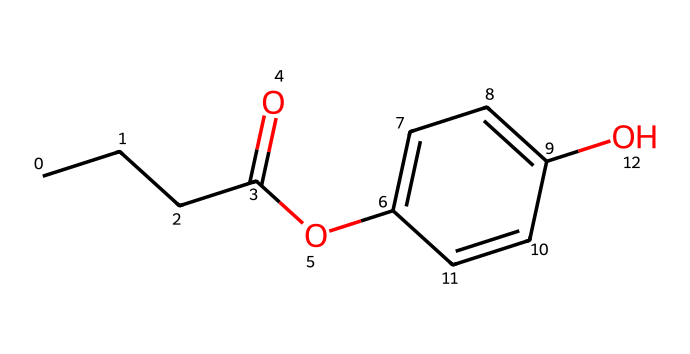What is the chemical name represented by this SMILES? The SMILES represents a specific structure that can be decoded to find the common name used for it. By interpreting the SMILES, we recognize it corresponds to "propylparaben," which is a known preservative.
Answer: propylparaben How many carbon atoms are in propylparaben? Looking at the structure represented by the SMILES, we can count the number of carbon atoms represented. In the SMILES, there are six carbon atoms (CCCC and C1, plus the ones in the aromatic ring).
Answer: six What functional group is present in propylparaben? The presence of the specific structure indicates functional groups in the molecule. From the SMILES, we observe the presence of both an ester (indicated by the "O" and the "C(=O)") and a hydroxyl group (–OH) on the aromatic ring, which point to "ester" being the primary functional group.
Answer: ester How many oxygen atoms are in propylparaben? Analyzing the SMILES notation, we identify the number of oxygen atoms present within the molecule. There are two oxygen atoms: one in the ester functional group (-O) and one as the hydroxyl group (-OH).
Answer: two How many double bonds are present in the structure of propylparaben? By examining the SMILES representation, we observe that there is one double bond in the carbonyl group (=O) of the ester, and there are additional double bonds in the aromatic carbon ring. However, specifically, there are three double bonds overall.
Answer: three Is propylparaben hydrophilic, hydrophobic, or amphiphilic? Considering the functional groups in propylparaben, which include a hydroxyl group that is hydrophilic and the long carbon chain that is more hydrophobic results in an overall amphiphilic characteristic for the molecule.
Answer: amphiphilic 